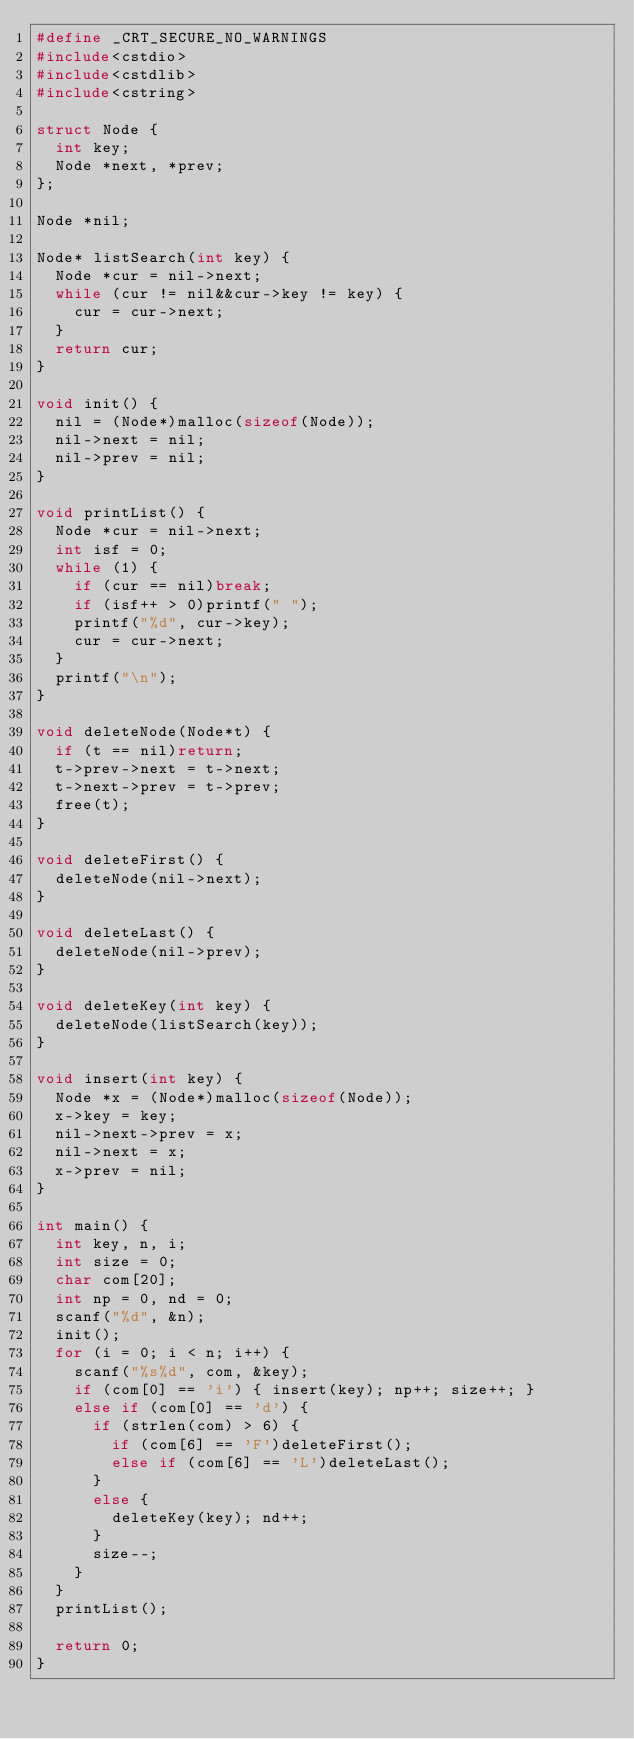<code> <loc_0><loc_0><loc_500><loc_500><_C++_>#define _CRT_SECURE_NO_WARNINGS
#include<cstdio>
#include<cstdlib>
#include<cstring>

struct Node {
	int key;
	Node *next, *prev;
};

Node *nil;

Node* listSearch(int key) {
	Node *cur = nil->next;
	while (cur != nil&&cur->key != key) {
		cur = cur->next;
	}
	return cur;
}

void init() {
	nil = (Node*)malloc(sizeof(Node));
	nil->next = nil;
	nil->prev = nil;
}

void printList() {
	Node *cur = nil->next;
	int isf = 0;
	while (1) {
		if (cur == nil)break;
		if (isf++ > 0)printf(" ");
		printf("%d", cur->key);
		cur = cur->next;
	}
	printf("\n");
}

void deleteNode(Node*t) {
	if (t == nil)return;
	t->prev->next = t->next;
	t->next->prev = t->prev;
	free(t);
}

void deleteFirst() {
	deleteNode(nil->next);
}

void deleteLast() {
	deleteNode(nil->prev);
}

void deleteKey(int key) {
	deleteNode(listSearch(key));
}

void insert(int key) {
	Node *x = (Node*)malloc(sizeof(Node));
	x->key = key;
	nil->next->prev = x;
	nil->next = x;
	x->prev = nil;
}

int main() {
	int key, n, i;
	int size = 0;
	char com[20];
	int np = 0, nd = 0;
	scanf("%d", &n);
	init();
	for (i = 0; i < n; i++) {
		scanf("%s%d", com, &key);
		if (com[0] == 'i') { insert(key); np++; size++; }
		else if (com[0] == 'd') {
			if (strlen(com) > 6) {
				if (com[6] == 'F')deleteFirst();
				else if (com[6] == 'L')deleteLast();
			}
			else {
				deleteKey(key); nd++;
			}
			size--;
		}
	}
	printList();
	
	return 0;
}</code> 